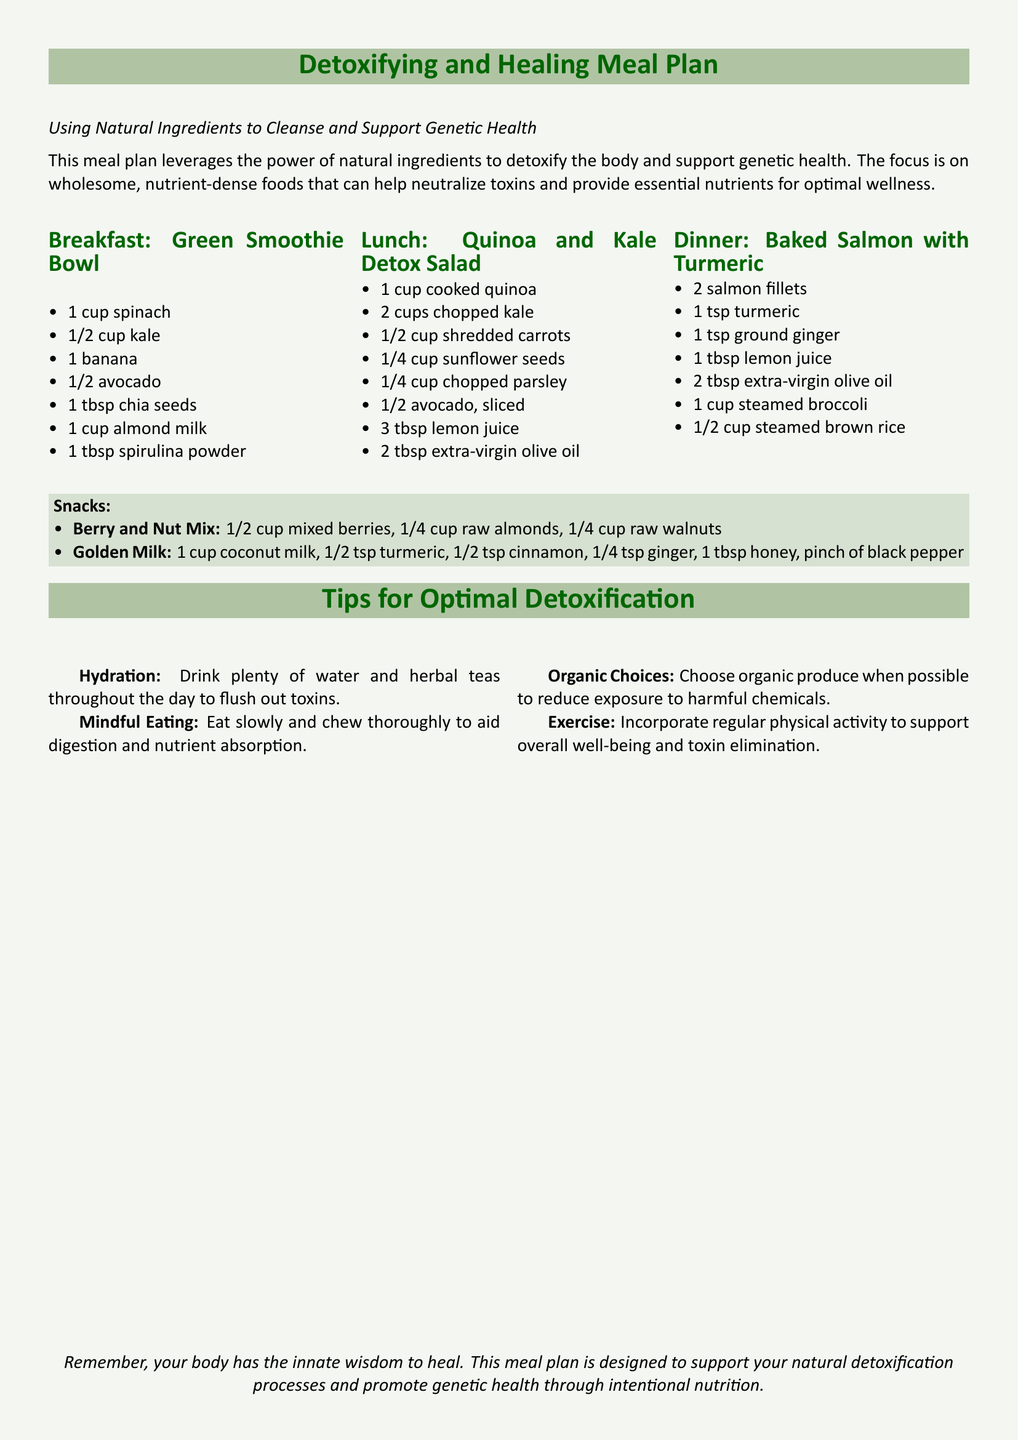what is the title of the meal plan? The title of the meal plan is found at the top of the document.
Answer: Detoxifying and Healing Meal Plan what are the main ingredients in the Breakfast smoothie? The main ingredients are listed under the Breakfast section of the document.
Answer: spinach, kale, banana, avocado, chia seeds, almond milk, spirulina powder how many snacks are suggested? The snacks section lists the number of snack options available in the meal plan.
Answer: 2 what is included in the Lunch salad? The lunch ingredients are detailed in the Lunch section of the document.
Answer: quinoa, kale, carrots, sunflower seeds, parsley, avocado, lemon juice, olive oil what is a key suggestion for detoxification? The tips provided in the document highlight specific suggestions for optimal detoxification.
Answer: Hydration what type of milk is used in the Golden Milk snack? The type of milk is mentioned in the snack details for Golden Milk.
Answer: coconut milk how many cups of chopped kale are in the Lunch salad? The measurement for kale is specified in the Lunch section of the document.
Answer: 2 cups what is the recommended oil to use in the Lunch salad? The type of oil is mentioned in the ingredients list for the Lunch salad.
Answer: extra-virgin olive oil 